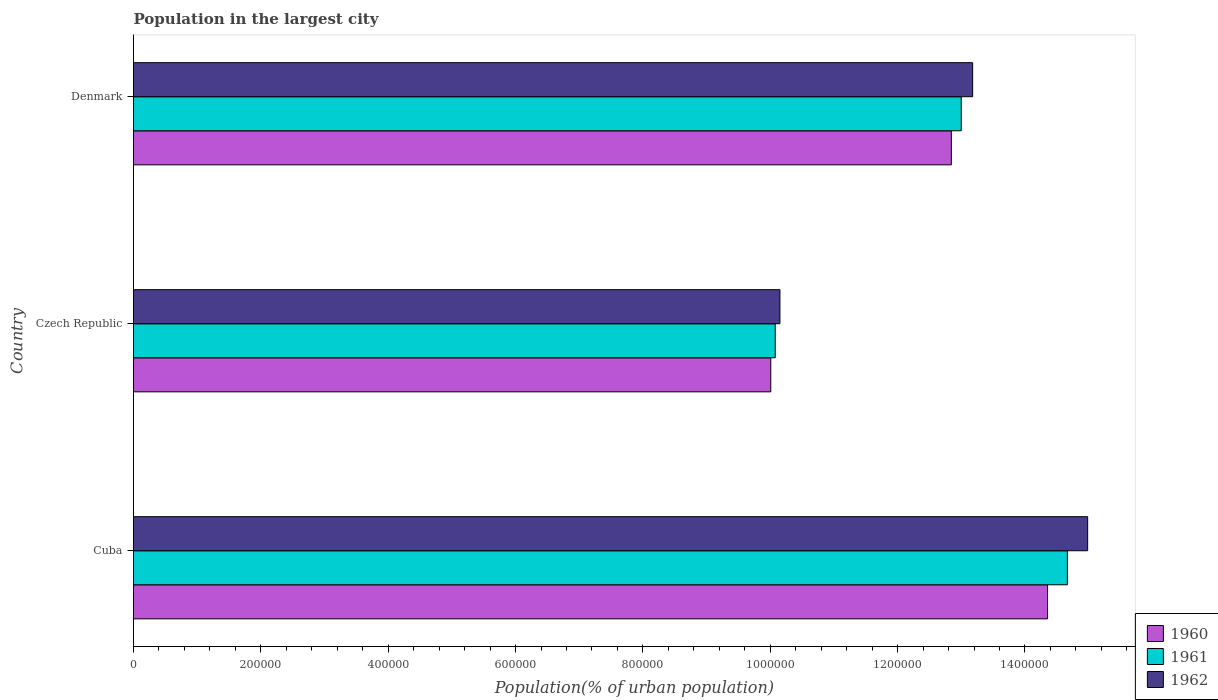Are the number of bars per tick equal to the number of legend labels?
Ensure brevity in your answer.  Yes. What is the label of the 3rd group of bars from the top?
Make the answer very short. Cuba. What is the population in the largest city in 1961 in Cuba?
Offer a terse response. 1.47e+06. Across all countries, what is the maximum population in the largest city in 1962?
Provide a short and direct response. 1.50e+06. Across all countries, what is the minimum population in the largest city in 1960?
Offer a terse response. 1.00e+06. In which country was the population in the largest city in 1960 maximum?
Keep it short and to the point. Cuba. In which country was the population in the largest city in 1961 minimum?
Offer a very short reply. Czech Republic. What is the total population in the largest city in 1961 in the graph?
Ensure brevity in your answer.  3.77e+06. What is the difference between the population in the largest city in 1962 in Cuba and that in Denmark?
Give a very brief answer. 1.81e+05. What is the difference between the population in the largest city in 1960 in Cuba and the population in the largest city in 1962 in Czech Republic?
Offer a very short reply. 4.20e+05. What is the average population in the largest city in 1960 per country?
Keep it short and to the point. 1.24e+06. What is the difference between the population in the largest city in 1960 and population in the largest city in 1961 in Cuba?
Offer a very short reply. -3.11e+04. In how many countries, is the population in the largest city in 1962 greater than 1200000 %?
Your response must be concise. 2. What is the ratio of the population in the largest city in 1962 in Cuba to that in Czech Republic?
Your answer should be very brief. 1.48. Is the population in the largest city in 1961 in Cuba less than that in Czech Republic?
Make the answer very short. No. What is the difference between the highest and the second highest population in the largest city in 1961?
Provide a succinct answer. 1.67e+05. What is the difference between the highest and the lowest population in the largest city in 1961?
Your answer should be compact. 4.59e+05. Is the sum of the population in the largest city in 1960 in Cuba and Denmark greater than the maximum population in the largest city in 1962 across all countries?
Provide a succinct answer. Yes. What does the 1st bar from the top in Cuba represents?
Offer a very short reply. 1962. Are all the bars in the graph horizontal?
Keep it short and to the point. Yes. Does the graph contain any zero values?
Offer a very short reply. No. Where does the legend appear in the graph?
Provide a succinct answer. Bottom right. How many legend labels are there?
Your response must be concise. 3. How are the legend labels stacked?
Ensure brevity in your answer.  Vertical. What is the title of the graph?
Give a very brief answer. Population in the largest city. What is the label or title of the X-axis?
Give a very brief answer. Population(% of urban population). What is the Population(% of urban population) in 1960 in Cuba?
Keep it short and to the point. 1.44e+06. What is the Population(% of urban population) in 1961 in Cuba?
Your response must be concise. 1.47e+06. What is the Population(% of urban population) in 1962 in Cuba?
Make the answer very short. 1.50e+06. What is the Population(% of urban population) in 1960 in Czech Republic?
Keep it short and to the point. 1.00e+06. What is the Population(% of urban population) of 1961 in Czech Republic?
Offer a terse response. 1.01e+06. What is the Population(% of urban population) of 1962 in Czech Republic?
Keep it short and to the point. 1.02e+06. What is the Population(% of urban population) in 1960 in Denmark?
Your answer should be very brief. 1.28e+06. What is the Population(% of urban population) in 1961 in Denmark?
Make the answer very short. 1.30e+06. What is the Population(% of urban population) in 1962 in Denmark?
Ensure brevity in your answer.  1.32e+06. Across all countries, what is the maximum Population(% of urban population) of 1960?
Offer a terse response. 1.44e+06. Across all countries, what is the maximum Population(% of urban population) of 1961?
Make the answer very short. 1.47e+06. Across all countries, what is the maximum Population(% of urban population) of 1962?
Your answer should be compact. 1.50e+06. Across all countries, what is the minimum Population(% of urban population) in 1960?
Provide a succinct answer. 1.00e+06. Across all countries, what is the minimum Population(% of urban population) in 1961?
Give a very brief answer. 1.01e+06. Across all countries, what is the minimum Population(% of urban population) in 1962?
Ensure brevity in your answer.  1.02e+06. What is the total Population(% of urban population) in 1960 in the graph?
Your answer should be compact. 3.72e+06. What is the total Population(% of urban population) in 1961 in the graph?
Make the answer very short. 3.77e+06. What is the total Population(% of urban population) of 1962 in the graph?
Your answer should be very brief. 3.83e+06. What is the difference between the Population(% of urban population) of 1960 in Cuba and that in Czech Republic?
Your answer should be compact. 4.35e+05. What is the difference between the Population(% of urban population) of 1961 in Cuba and that in Czech Republic?
Your answer should be very brief. 4.59e+05. What is the difference between the Population(% of urban population) in 1962 in Cuba and that in Czech Republic?
Your answer should be compact. 4.83e+05. What is the difference between the Population(% of urban population) of 1960 in Cuba and that in Denmark?
Your answer should be compact. 1.51e+05. What is the difference between the Population(% of urban population) in 1961 in Cuba and that in Denmark?
Offer a very short reply. 1.67e+05. What is the difference between the Population(% of urban population) in 1962 in Cuba and that in Denmark?
Keep it short and to the point. 1.81e+05. What is the difference between the Population(% of urban population) of 1960 in Czech Republic and that in Denmark?
Offer a very short reply. -2.84e+05. What is the difference between the Population(% of urban population) in 1961 in Czech Republic and that in Denmark?
Give a very brief answer. -2.92e+05. What is the difference between the Population(% of urban population) in 1962 in Czech Republic and that in Denmark?
Make the answer very short. -3.03e+05. What is the difference between the Population(% of urban population) in 1960 in Cuba and the Population(% of urban population) in 1961 in Czech Republic?
Keep it short and to the point. 4.28e+05. What is the difference between the Population(% of urban population) in 1960 in Cuba and the Population(% of urban population) in 1962 in Czech Republic?
Your answer should be very brief. 4.20e+05. What is the difference between the Population(% of urban population) of 1961 in Cuba and the Population(% of urban population) of 1962 in Czech Republic?
Ensure brevity in your answer.  4.51e+05. What is the difference between the Population(% of urban population) in 1960 in Cuba and the Population(% of urban population) in 1961 in Denmark?
Give a very brief answer. 1.36e+05. What is the difference between the Population(% of urban population) of 1960 in Cuba and the Population(% of urban population) of 1962 in Denmark?
Your answer should be compact. 1.18e+05. What is the difference between the Population(% of urban population) of 1961 in Cuba and the Population(% of urban population) of 1962 in Denmark?
Offer a terse response. 1.49e+05. What is the difference between the Population(% of urban population) of 1960 in Czech Republic and the Population(% of urban population) of 1961 in Denmark?
Provide a succinct answer. -2.99e+05. What is the difference between the Population(% of urban population) of 1960 in Czech Republic and the Population(% of urban population) of 1962 in Denmark?
Provide a short and direct response. -3.17e+05. What is the difference between the Population(% of urban population) in 1961 in Czech Republic and the Population(% of urban population) in 1962 in Denmark?
Ensure brevity in your answer.  -3.10e+05. What is the average Population(% of urban population) of 1960 per country?
Make the answer very short. 1.24e+06. What is the average Population(% of urban population) of 1961 per country?
Your response must be concise. 1.26e+06. What is the average Population(% of urban population) in 1962 per country?
Provide a short and direct response. 1.28e+06. What is the difference between the Population(% of urban population) of 1960 and Population(% of urban population) of 1961 in Cuba?
Provide a succinct answer. -3.11e+04. What is the difference between the Population(% of urban population) in 1960 and Population(% of urban population) in 1962 in Cuba?
Give a very brief answer. -6.30e+04. What is the difference between the Population(% of urban population) in 1961 and Population(% of urban population) in 1962 in Cuba?
Your answer should be compact. -3.18e+04. What is the difference between the Population(% of urban population) in 1960 and Population(% of urban population) in 1961 in Czech Republic?
Provide a succinct answer. -7004. What is the difference between the Population(% of urban population) in 1960 and Population(% of urban population) in 1962 in Czech Republic?
Give a very brief answer. -1.44e+04. What is the difference between the Population(% of urban population) in 1961 and Population(% of urban population) in 1962 in Czech Republic?
Provide a short and direct response. -7379. What is the difference between the Population(% of urban population) of 1960 and Population(% of urban population) of 1961 in Denmark?
Your response must be concise. -1.55e+04. What is the difference between the Population(% of urban population) of 1960 and Population(% of urban population) of 1962 in Denmark?
Offer a terse response. -3.34e+04. What is the difference between the Population(% of urban population) of 1961 and Population(% of urban population) of 1962 in Denmark?
Provide a short and direct response. -1.79e+04. What is the ratio of the Population(% of urban population) of 1960 in Cuba to that in Czech Republic?
Your answer should be very brief. 1.43. What is the ratio of the Population(% of urban population) of 1961 in Cuba to that in Czech Republic?
Provide a short and direct response. 1.46. What is the ratio of the Population(% of urban population) of 1962 in Cuba to that in Czech Republic?
Make the answer very short. 1.48. What is the ratio of the Population(% of urban population) in 1960 in Cuba to that in Denmark?
Your response must be concise. 1.12. What is the ratio of the Population(% of urban population) in 1961 in Cuba to that in Denmark?
Offer a terse response. 1.13. What is the ratio of the Population(% of urban population) of 1962 in Cuba to that in Denmark?
Provide a succinct answer. 1.14. What is the ratio of the Population(% of urban population) in 1960 in Czech Republic to that in Denmark?
Give a very brief answer. 0.78. What is the ratio of the Population(% of urban population) in 1961 in Czech Republic to that in Denmark?
Give a very brief answer. 0.78. What is the ratio of the Population(% of urban population) in 1962 in Czech Republic to that in Denmark?
Your response must be concise. 0.77. What is the difference between the highest and the second highest Population(% of urban population) in 1960?
Your answer should be very brief. 1.51e+05. What is the difference between the highest and the second highest Population(% of urban population) in 1961?
Your answer should be very brief. 1.67e+05. What is the difference between the highest and the second highest Population(% of urban population) of 1962?
Your answer should be compact. 1.81e+05. What is the difference between the highest and the lowest Population(% of urban population) of 1960?
Provide a short and direct response. 4.35e+05. What is the difference between the highest and the lowest Population(% of urban population) in 1961?
Provide a succinct answer. 4.59e+05. What is the difference between the highest and the lowest Population(% of urban population) in 1962?
Keep it short and to the point. 4.83e+05. 